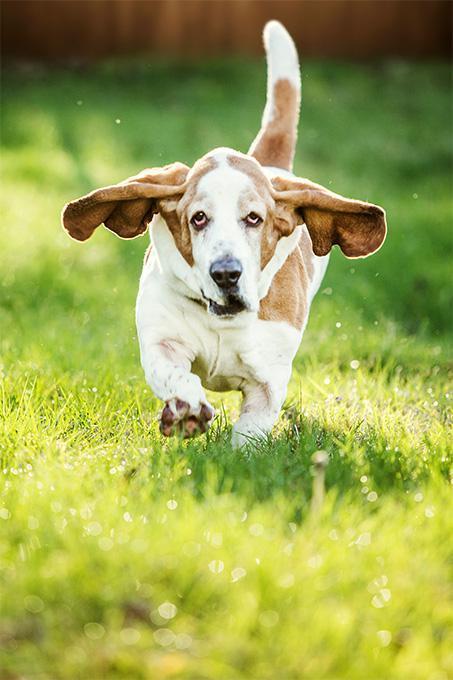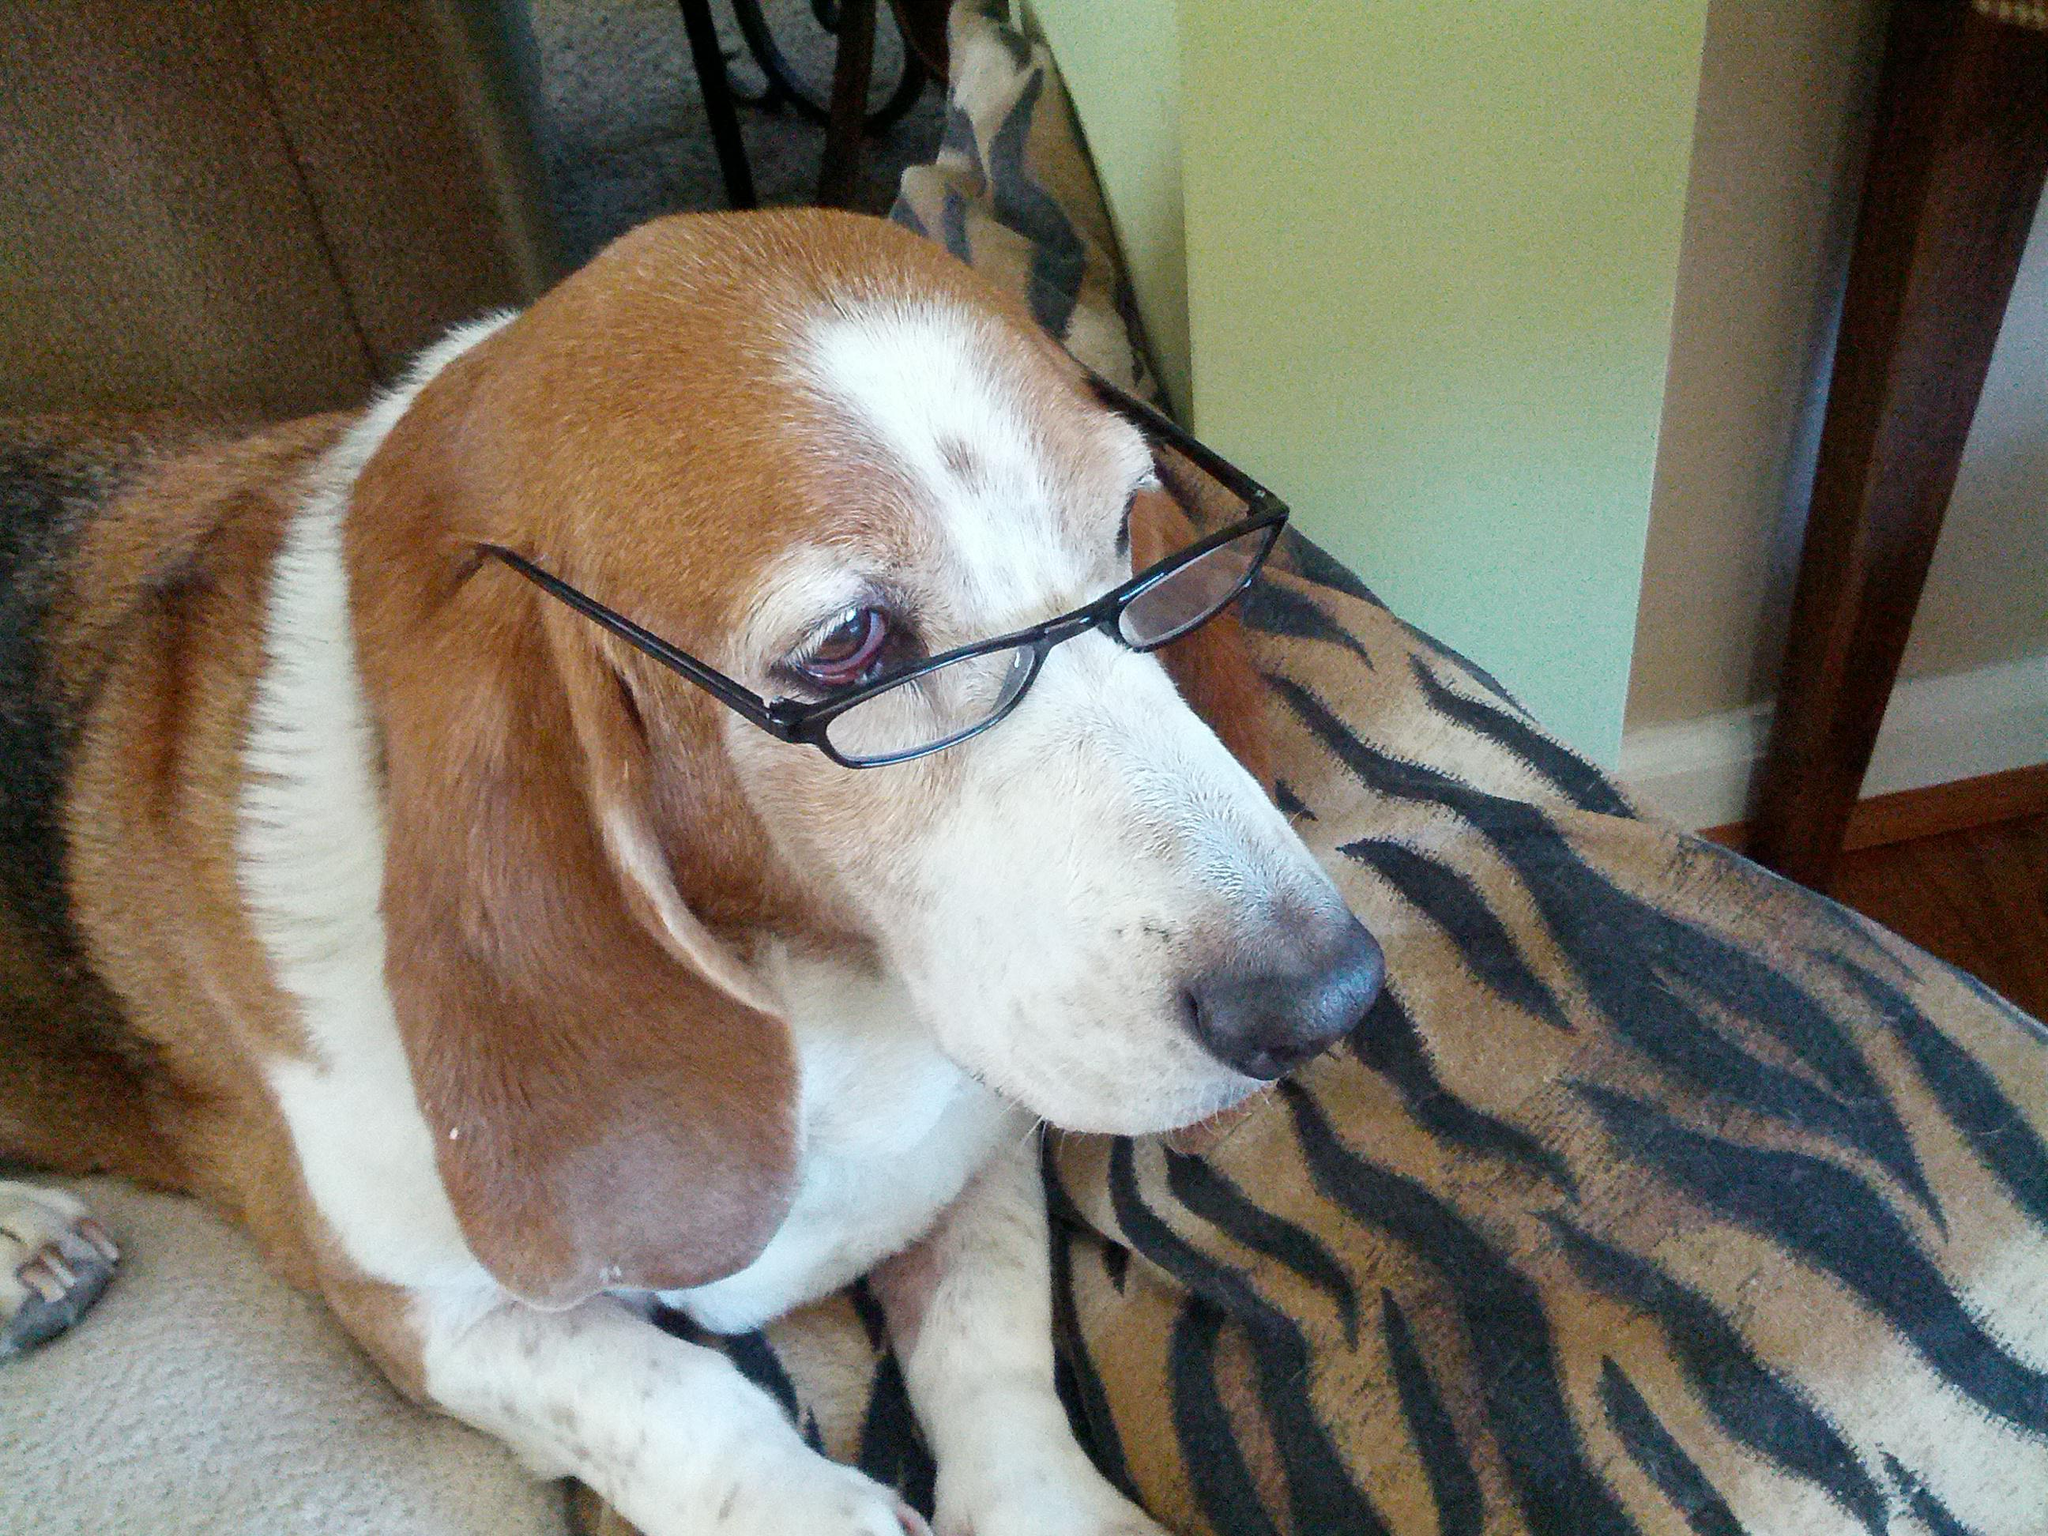The first image is the image on the left, the second image is the image on the right. Considering the images on both sides, is "Two basset hounds face the camera and are not standing on grass." valid? Answer yes or no. No. The first image is the image on the left, the second image is the image on the right. Analyze the images presented: Is the assertion "At least one dog is standing on grass." valid? Answer yes or no. Yes. 